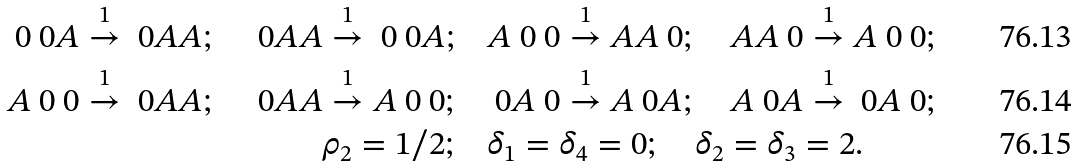Convert formula to latex. <formula><loc_0><loc_0><loc_500><loc_500>\ 0 \ 0 A \overset { 1 } { \to } \ 0 A A ; \quad \ 0 A A \overset { 1 } { \to } \ 0 \ 0 A ; & \quad A \ 0 \ 0 \overset { 1 } { \to } A A \ 0 ; \quad A A \ 0 \overset { 1 } { \to } A \ 0 \ 0 ; \\ A \ 0 \ 0 \overset { 1 } { \to } \ 0 A A ; \quad \ 0 A A \overset { 1 } { \to } A \ 0 \ 0 ; & \quad \ 0 A \ 0 \overset { 1 } { \to } A \ 0 A ; \quad A \ 0 A \overset { 1 } { \to } \ 0 A \ 0 ; \\ \rho _ { 2 } = 1 / 2 ; & \quad \delta _ { 1 } = \delta _ { 4 } = 0 ; \quad \delta _ { 2 } = \delta _ { 3 } = 2 .</formula> 